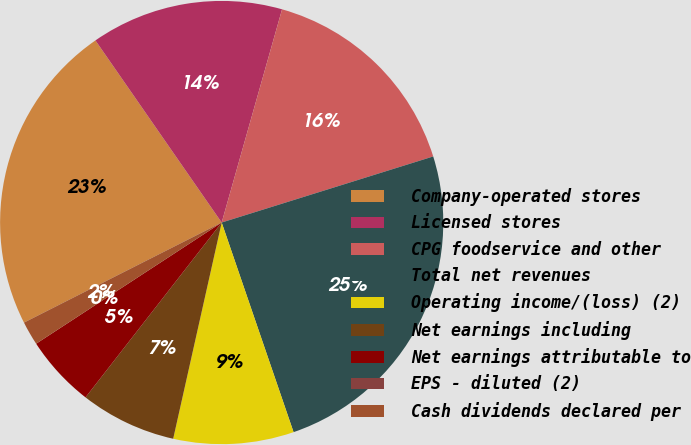<chart> <loc_0><loc_0><loc_500><loc_500><pie_chart><fcel>Company-operated stores<fcel>Licensed stores<fcel>CPG foodservice and other<fcel>Total net revenues<fcel>Operating income/(loss) (2)<fcel>Net earnings including<fcel>Net earnings attributable to<fcel>EPS - diluted (2)<fcel>Cash dividends declared per<nl><fcel>22.81%<fcel>14.04%<fcel>15.79%<fcel>24.56%<fcel>8.77%<fcel>7.02%<fcel>5.26%<fcel>0.0%<fcel>1.75%<nl></chart> 